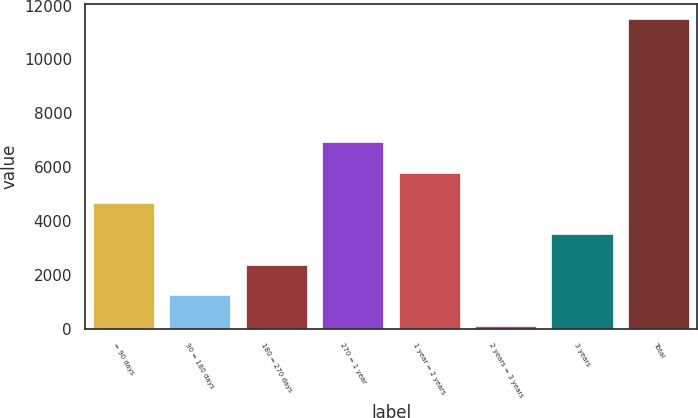Convert chart to OTSL. <chart><loc_0><loc_0><loc_500><loc_500><bar_chart><fcel>= 90 days<fcel>90 = 180 days<fcel>180 = 270 days<fcel>270 = 1 year<fcel>1 year = 2 years<fcel>2 years = 3 years<fcel>3 years<fcel>Total<nl><fcel>4660.08<fcel>1248.27<fcel>2385.54<fcel>6934.62<fcel>5797.35<fcel>111<fcel>3522.81<fcel>11483.7<nl></chart> 